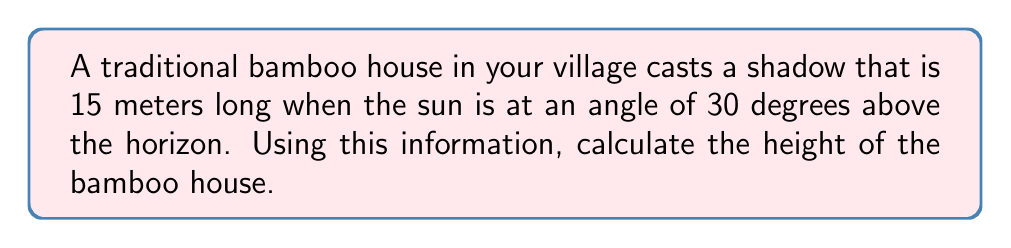Give your solution to this math problem. To solve this problem, we'll use trigonometry. Let's break it down step-by-step:

1) First, let's visualize the situation:

   [asy]
   import geometry;
   
   size(200);
   
   pair A = (0,0), B = (15,0), C = (0,8.66);
   
   draw(A--B--C--A);
   
   label("15 m", (7.5,0), S);
   label("30°", (0,0), SW);
   label("h", (0,4.33), W);
   
   draw(rightanglemark(A,B,C,2));
   [/asy]

2) In this right-angled triangle, we know:
   - The length of the shadow (adjacent side) = 15 meters
   - The angle of the sun = 30°

3) We need to find the height of the house (opposite side). The trigonometric ratio that relates the opposite side to the adjacent side is the tangent.

4) The formula is:
   $$\tan(\theta) = \frac{\text{opposite}}{\text{adjacent}}$$

5) Substituting our known values:
   $$\tan(30°) = \frac{h}{15}$$

6) We know that $\tan(30°) = \frac{1}{\sqrt{3}}$, so:
   $$\frac{1}{\sqrt{3}} = \frac{h}{15}$$

7) Cross-multiply:
   $$15 \cdot \frac{1}{\sqrt{3}} = h$$

8) Simplify:
   $$\frac{15}{\sqrt{3}} = h$$

9) To rationalize the denominator:
   $$\frac{15}{\sqrt{3}} \cdot \frac{\sqrt{3}}{\sqrt{3}} = h$$

10) Simplify:
    $$\frac{15\sqrt{3}}{3} = h$$

11) Calculate:
    $$5\sqrt{3} \approx 8.66 \text{ meters}$$
Answer: $5\sqrt{3}$ meters (approximately 8.66 meters) 